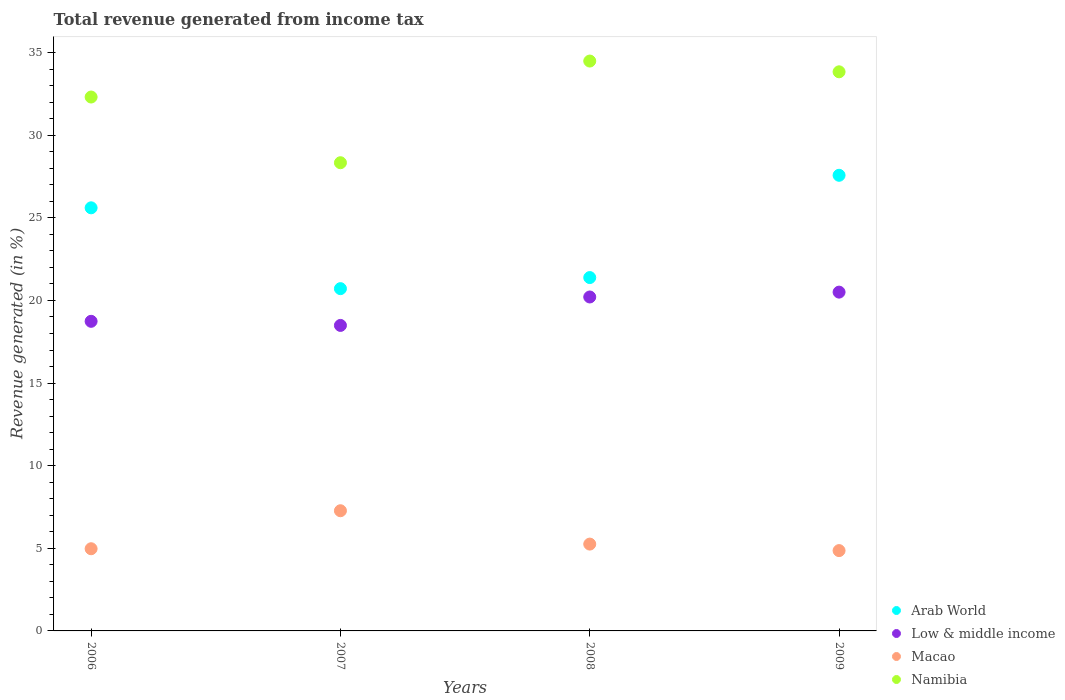How many different coloured dotlines are there?
Your response must be concise. 4. What is the total revenue generated in Macao in 2006?
Your response must be concise. 4.97. Across all years, what is the maximum total revenue generated in Namibia?
Your answer should be compact. 34.49. Across all years, what is the minimum total revenue generated in Namibia?
Offer a terse response. 28.33. What is the total total revenue generated in Namibia in the graph?
Keep it short and to the point. 128.97. What is the difference between the total revenue generated in Arab World in 2007 and that in 2008?
Offer a terse response. -0.67. What is the difference between the total revenue generated in Macao in 2006 and the total revenue generated in Low & middle income in 2007?
Offer a very short reply. -13.52. What is the average total revenue generated in Arab World per year?
Your answer should be very brief. 23.82. In the year 2009, what is the difference between the total revenue generated in Arab World and total revenue generated in Low & middle income?
Ensure brevity in your answer.  7.07. What is the ratio of the total revenue generated in Arab World in 2008 to that in 2009?
Provide a short and direct response. 0.78. Is the total revenue generated in Namibia in 2007 less than that in 2009?
Your answer should be very brief. Yes. What is the difference between the highest and the second highest total revenue generated in Macao?
Ensure brevity in your answer.  2.02. What is the difference between the highest and the lowest total revenue generated in Arab World?
Make the answer very short. 6.86. In how many years, is the total revenue generated in Low & middle income greater than the average total revenue generated in Low & middle income taken over all years?
Make the answer very short. 2. Is it the case that in every year, the sum of the total revenue generated in Arab World and total revenue generated in Macao  is greater than the sum of total revenue generated in Low & middle income and total revenue generated in Namibia?
Your answer should be compact. No. Is it the case that in every year, the sum of the total revenue generated in Namibia and total revenue generated in Arab World  is greater than the total revenue generated in Low & middle income?
Offer a very short reply. Yes. How many years are there in the graph?
Your answer should be very brief. 4. Are the values on the major ticks of Y-axis written in scientific E-notation?
Your answer should be compact. No. Does the graph contain any zero values?
Provide a short and direct response. No. Where does the legend appear in the graph?
Provide a succinct answer. Bottom right. How many legend labels are there?
Your answer should be compact. 4. How are the legend labels stacked?
Make the answer very short. Vertical. What is the title of the graph?
Your answer should be compact. Total revenue generated from income tax. What is the label or title of the X-axis?
Give a very brief answer. Years. What is the label or title of the Y-axis?
Offer a very short reply. Revenue generated (in %). What is the Revenue generated (in %) of Arab World in 2006?
Your answer should be very brief. 25.61. What is the Revenue generated (in %) of Low & middle income in 2006?
Offer a very short reply. 18.74. What is the Revenue generated (in %) of Macao in 2006?
Your answer should be very brief. 4.97. What is the Revenue generated (in %) in Namibia in 2006?
Keep it short and to the point. 32.31. What is the Revenue generated (in %) of Arab World in 2007?
Provide a short and direct response. 20.71. What is the Revenue generated (in %) in Low & middle income in 2007?
Provide a succinct answer. 18.49. What is the Revenue generated (in %) in Macao in 2007?
Ensure brevity in your answer.  7.27. What is the Revenue generated (in %) in Namibia in 2007?
Offer a very short reply. 28.33. What is the Revenue generated (in %) of Arab World in 2008?
Give a very brief answer. 21.38. What is the Revenue generated (in %) of Low & middle income in 2008?
Your answer should be compact. 20.21. What is the Revenue generated (in %) of Macao in 2008?
Provide a short and direct response. 5.25. What is the Revenue generated (in %) in Namibia in 2008?
Your answer should be compact. 34.49. What is the Revenue generated (in %) of Arab World in 2009?
Your answer should be compact. 27.57. What is the Revenue generated (in %) of Low & middle income in 2009?
Your answer should be very brief. 20.5. What is the Revenue generated (in %) in Macao in 2009?
Give a very brief answer. 4.86. What is the Revenue generated (in %) of Namibia in 2009?
Ensure brevity in your answer.  33.84. Across all years, what is the maximum Revenue generated (in %) in Arab World?
Offer a very short reply. 27.57. Across all years, what is the maximum Revenue generated (in %) of Low & middle income?
Ensure brevity in your answer.  20.5. Across all years, what is the maximum Revenue generated (in %) of Macao?
Provide a succinct answer. 7.27. Across all years, what is the maximum Revenue generated (in %) in Namibia?
Ensure brevity in your answer.  34.49. Across all years, what is the minimum Revenue generated (in %) in Arab World?
Give a very brief answer. 20.71. Across all years, what is the minimum Revenue generated (in %) of Low & middle income?
Offer a terse response. 18.49. Across all years, what is the minimum Revenue generated (in %) in Macao?
Ensure brevity in your answer.  4.86. Across all years, what is the minimum Revenue generated (in %) in Namibia?
Provide a succinct answer. 28.33. What is the total Revenue generated (in %) of Arab World in the graph?
Make the answer very short. 95.28. What is the total Revenue generated (in %) in Low & middle income in the graph?
Your answer should be very brief. 77.94. What is the total Revenue generated (in %) of Macao in the graph?
Offer a very short reply. 22.36. What is the total Revenue generated (in %) of Namibia in the graph?
Offer a very short reply. 128.97. What is the difference between the Revenue generated (in %) of Arab World in 2006 and that in 2007?
Offer a very short reply. 4.89. What is the difference between the Revenue generated (in %) in Low & middle income in 2006 and that in 2007?
Make the answer very short. 0.25. What is the difference between the Revenue generated (in %) of Macao in 2006 and that in 2007?
Make the answer very short. -2.3. What is the difference between the Revenue generated (in %) of Namibia in 2006 and that in 2007?
Your answer should be very brief. 3.98. What is the difference between the Revenue generated (in %) of Arab World in 2006 and that in 2008?
Give a very brief answer. 4.22. What is the difference between the Revenue generated (in %) of Low & middle income in 2006 and that in 2008?
Provide a short and direct response. -1.47. What is the difference between the Revenue generated (in %) in Macao in 2006 and that in 2008?
Provide a short and direct response. -0.28. What is the difference between the Revenue generated (in %) in Namibia in 2006 and that in 2008?
Offer a very short reply. -2.18. What is the difference between the Revenue generated (in %) in Arab World in 2006 and that in 2009?
Provide a succinct answer. -1.97. What is the difference between the Revenue generated (in %) of Low & middle income in 2006 and that in 2009?
Your answer should be compact. -1.77. What is the difference between the Revenue generated (in %) of Macao in 2006 and that in 2009?
Make the answer very short. 0.11. What is the difference between the Revenue generated (in %) in Namibia in 2006 and that in 2009?
Your answer should be compact. -1.53. What is the difference between the Revenue generated (in %) in Arab World in 2007 and that in 2008?
Provide a short and direct response. -0.67. What is the difference between the Revenue generated (in %) of Low & middle income in 2007 and that in 2008?
Your answer should be compact. -1.72. What is the difference between the Revenue generated (in %) in Macao in 2007 and that in 2008?
Make the answer very short. 2.02. What is the difference between the Revenue generated (in %) of Namibia in 2007 and that in 2008?
Offer a terse response. -6.15. What is the difference between the Revenue generated (in %) in Arab World in 2007 and that in 2009?
Your response must be concise. -6.86. What is the difference between the Revenue generated (in %) of Low & middle income in 2007 and that in 2009?
Offer a terse response. -2.02. What is the difference between the Revenue generated (in %) in Macao in 2007 and that in 2009?
Keep it short and to the point. 2.41. What is the difference between the Revenue generated (in %) in Namibia in 2007 and that in 2009?
Keep it short and to the point. -5.5. What is the difference between the Revenue generated (in %) of Arab World in 2008 and that in 2009?
Give a very brief answer. -6.19. What is the difference between the Revenue generated (in %) of Low & middle income in 2008 and that in 2009?
Your answer should be compact. -0.29. What is the difference between the Revenue generated (in %) in Macao in 2008 and that in 2009?
Provide a short and direct response. 0.39. What is the difference between the Revenue generated (in %) in Namibia in 2008 and that in 2009?
Your response must be concise. 0.65. What is the difference between the Revenue generated (in %) of Arab World in 2006 and the Revenue generated (in %) of Low & middle income in 2007?
Ensure brevity in your answer.  7.12. What is the difference between the Revenue generated (in %) in Arab World in 2006 and the Revenue generated (in %) in Macao in 2007?
Give a very brief answer. 18.33. What is the difference between the Revenue generated (in %) in Arab World in 2006 and the Revenue generated (in %) in Namibia in 2007?
Keep it short and to the point. -2.73. What is the difference between the Revenue generated (in %) in Low & middle income in 2006 and the Revenue generated (in %) in Macao in 2007?
Make the answer very short. 11.46. What is the difference between the Revenue generated (in %) in Low & middle income in 2006 and the Revenue generated (in %) in Namibia in 2007?
Provide a short and direct response. -9.6. What is the difference between the Revenue generated (in %) in Macao in 2006 and the Revenue generated (in %) in Namibia in 2007?
Offer a terse response. -23.36. What is the difference between the Revenue generated (in %) of Arab World in 2006 and the Revenue generated (in %) of Low & middle income in 2008?
Offer a very short reply. 5.4. What is the difference between the Revenue generated (in %) of Arab World in 2006 and the Revenue generated (in %) of Macao in 2008?
Offer a very short reply. 20.35. What is the difference between the Revenue generated (in %) of Arab World in 2006 and the Revenue generated (in %) of Namibia in 2008?
Your answer should be compact. -8.88. What is the difference between the Revenue generated (in %) in Low & middle income in 2006 and the Revenue generated (in %) in Macao in 2008?
Your response must be concise. 13.48. What is the difference between the Revenue generated (in %) of Low & middle income in 2006 and the Revenue generated (in %) of Namibia in 2008?
Give a very brief answer. -15.75. What is the difference between the Revenue generated (in %) in Macao in 2006 and the Revenue generated (in %) in Namibia in 2008?
Provide a succinct answer. -29.51. What is the difference between the Revenue generated (in %) in Arab World in 2006 and the Revenue generated (in %) in Low & middle income in 2009?
Give a very brief answer. 5.1. What is the difference between the Revenue generated (in %) in Arab World in 2006 and the Revenue generated (in %) in Macao in 2009?
Give a very brief answer. 20.75. What is the difference between the Revenue generated (in %) of Arab World in 2006 and the Revenue generated (in %) of Namibia in 2009?
Your answer should be compact. -8.23. What is the difference between the Revenue generated (in %) in Low & middle income in 2006 and the Revenue generated (in %) in Macao in 2009?
Offer a very short reply. 13.88. What is the difference between the Revenue generated (in %) in Low & middle income in 2006 and the Revenue generated (in %) in Namibia in 2009?
Your answer should be very brief. -15.1. What is the difference between the Revenue generated (in %) of Macao in 2006 and the Revenue generated (in %) of Namibia in 2009?
Make the answer very short. -28.86. What is the difference between the Revenue generated (in %) of Arab World in 2007 and the Revenue generated (in %) of Low & middle income in 2008?
Make the answer very short. 0.5. What is the difference between the Revenue generated (in %) of Arab World in 2007 and the Revenue generated (in %) of Macao in 2008?
Offer a terse response. 15.46. What is the difference between the Revenue generated (in %) of Arab World in 2007 and the Revenue generated (in %) of Namibia in 2008?
Offer a terse response. -13.77. What is the difference between the Revenue generated (in %) in Low & middle income in 2007 and the Revenue generated (in %) in Macao in 2008?
Your answer should be compact. 13.23. What is the difference between the Revenue generated (in %) of Low & middle income in 2007 and the Revenue generated (in %) of Namibia in 2008?
Provide a short and direct response. -16. What is the difference between the Revenue generated (in %) in Macao in 2007 and the Revenue generated (in %) in Namibia in 2008?
Provide a short and direct response. -27.21. What is the difference between the Revenue generated (in %) in Arab World in 2007 and the Revenue generated (in %) in Low & middle income in 2009?
Make the answer very short. 0.21. What is the difference between the Revenue generated (in %) in Arab World in 2007 and the Revenue generated (in %) in Macao in 2009?
Keep it short and to the point. 15.85. What is the difference between the Revenue generated (in %) in Arab World in 2007 and the Revenue generated (in %) in Namibia in 2009?
Provide a short and direct response. -13.12. What is the difference between the Revenue generated (in %) in Low & middle income in 2007 and the Revenue generated (in %) in Macao in 2009?
Your answer should be very brief. 13.63. What is the difference between the Revenue generated (in %) in Low & middle income in 2007 and the Revenue generated (in %) in Namibia in 2009?
Your response must be concise. -15.35. What is the difference between the Revenue generated (in %) of Macao in 2007 and the Revenue generated (in %) of Namibia in 2009?
Give a very brief answer. -26.56. What is the difference between the Revenue generated (in %) of Arab World in 2008 and the Revenue generated (in %) of Low & middle income in 2009?
Your answer should be compact. 0.88. What is the difference between the Revenue generated (in %) in Arab World in 2008 and the Revenue generated (in %) in Macao in 2009?
Your response must be concise. 16.52. What is the difference between the Revenue generated (in %) in Arab World in 2008 and the Revenue generated (in %) in Namibia in 2009?
Offer a terse response. -12.45. What is the difference between the Revenue generated (in %) of Low & middle income in 2008 and the Revenue generated (in %) of Macao in 2009?
Your response must be concise. 15.35. What is the difference between the Revenue generated (in %) of Low & middle income in 2008 and the Revenue generated (in %) of Namibia in 2009?
Give a very brief answer. -13.63. What is the difference between the Revenue generated (in %) of Macao in 2008 and the Revenue generated (in %) of Namibia in 2009?
Provide a succinct answer. -28.58. What is the average Revenue generated (in %) in Arab World per year?
Offer a terse response. 23.82. What is the average Revenue generated (in %) of Low & middle income per year?
Make the answer very short. 19.48. What is the average Revenue generated (in %) in Macao per year?
Your answer should be compact. 5.59. What is the average Revenue generated (in %) of Namibia per year?
Give a very brief answer. 32.24. In the year 2006, what is the difference between the Revenue generated (in %) of Arab World and Revenue generated (in %) of Low & middle income?
Provide a short and direct response. 6.87. In the year 2006, what is the difference between the Revenue generated (in %) in Arab World and Revenue generated (in %) in Macao?
Offer a very short reply. 20.63. In the year 2006, what is the difference between the Revenue generated (in %) of Arab World and Revenue generated (in %) of Namibia?
Provide a succinct answer. -6.7. In the year 2006, what is the difference between the Revenue generated (in %) of Low & middle income and Revenue generated (in %) of Macao?
Offer a terse response. 13.76. In the year 2006, what is the difference between the Revenue generated (in %) in Low & middle income and Revenue generated (in %) in Namibia?
Make the answer very short. -13.57. In the year 2006, what is the difference between the Revenue generated (in %) of Macao and Revenue generated (in %) of Namibia?
Your answer should be compact. -27.34. In the year 2007, what is the difference between the Revenue generated (in %) in Arab World and Revenue generated (in %) in Low & middle income?
Keep it short and to the point. 2.23. In the year 2007, what is the difference between the Revenue generated (in %) in Arab World and Revenue generated (in %) in Macao?
Offer a very short reply. 13.44. In the year 2007, what is the difference between the Revenue generated (in %) of Arab World and Revenue generated (in %) of Namibia?
Offer a terse response. -7.62. In the year 2007, what is the difference between the Revenue generated (in %) in Low & middle income and Revenue generated (in %) in Macao?
Provide a succinct answer. 11.22. In the year 2007, what is the difference between the Revenue generated (in %) of Low & middle income and Revenue generated (in %) of Namibia?
Give a very brief answer. -9.85. In the year 2007, what is the difference between the Revenue generated (in %) in Macao and Revenue generated (in %) in Namibia?
Give a very brief answer. -21.06. In the year 2008, what is the difference between the Revenue generated (in %) in Arab World and Revenue generated (in %) in Low & middle income?
Provide a succinct answer. 1.18. In the year 2008, what is the difference between the Revenue generated (in %) in Arab World and Revenue generated (in %) in Macao?
Your answer should be very brief. 16.13. In the year 2008, what is the difference between the Revenue generated (in %) of Arab World and Revenue generated (in %) of Namibia?
Make the answer very short. -13.1. In the year 2008, what is the difference between the Revenue generated (in %) of Low & middle income and Revenue generated (in %) of Macao?
Offer a terse response. 14.95. In the year 2008, what is the difference between the Revenue generated (in %) of Low & middle income and Revenue generated (in %) of Namibia?
Offer a terse response. -14.28. In the year 2008, what is the difference between the Revenue generated (in %) in Macao and Revenue generated (in %) in Namibia?
Provide a short and direct response. -29.23. In the year 2009, what is the difference between the Revenue generated (in %) in Arab World and Revenue generated (in %) in Low & middle income?
Ensure brevity in your answer.  7.07. In the year 2009, what is the difference between the Revenue generated (in %) in Arab World and Revenue generated (in %) in Macao?
Make the answer very short. 22.71. In the year 2009, what is the difference between the Revenue generated (in %) of Arab World and Revenue generated (in %) of Namibia?
Offer a very short reply. -6.26. In the year 2009, what is the difference between the Revenue generated (in %) in Low & middle income and Revenue generated (in %) in Macao?
Give a very brief answer. 15.64. In the year 2009, what is the difference between the Revenue generated (in %) of Low & middle income and Revenue generated (in %) of Namibia?
Offer a terse response. -13.33. In the year 2009, what is the difference between the Revenue generated (in %) in Macao and Revenue generated (in %) in Namibia?
Ensure brevity in your answer.  -28.98. What is the ratio of the Revenue generated (in %) of Arab World in 2006 to that in 2007?
Offer a very short reply. 1.24. What is the ratio of the Revenue generated (in %) in Low & middle income in 2006 to that in 2007?
Offer a terse response. 1.01. What is the ratio of the Revenue generated (in %) of Macao in 2006 to that in 2007?
Your response must be concise. 0.68. What is the ratio of the Revenue generated (in %) of Namibia in 2006 to that in 2007?
Offer a very short reply. 1.14. What is the ratio of the Revenue generated (in %) in Arab World in 2006 to that in 2008?
Provide a short and direct response. 1.2. What is the ratio of the Revenue generated (in %) of Low & middle income in 2006 to that in 2008?
Give a very brief answer. 0.93. What is the ratio of the Revenue generated (in %) in Macao in 2006 to that in 2008?
Your answer should be very brief. 0.95. What is the ratio of the Revenue generated (in %) of Namibia in 2006 to that in 2008?
Keep it short and to the point. 0.94. What is the ratio of the Revenue generated (in %) of Arab World in 2006 to that in 2009?
Give a very brief answer. 0.93. What is the ratio of the Revenue generated (in %) in Low & middle income in 2006 to that in 2009?
Give a very brief answer. 0.91. What is the ratio of the Revenue generated (in %) in Macao in 2006 to that in 2009?
Ensure brevity in your answer.  1.02. What is the ratio of the Revenue generated (in %) of Namibia in 2006 to that in 2009?
Offer a terse response. 0.95. What is the ratio of the Revenue generated (in %) of Arab World in 2007 to that in 2008?
Give a very brief answer. 0.97. What is the ratio of the Revenue generated (in %) in Low & middle income in 2007 to that in 2008?
Your answer should be very brief. 0.91. What is the ratio of the Revenue generated (in %) of Macao in 2007 to that in 2008?
Ensure brevity in your answer.  1.38. What is the ratio of the Revenue generated (in %) of Namibia in 2007 to that in 2008?
Make the answer very short. 0.82. What is the ratio of the Revenue generated (in %) of Arab World in 2007 to that in 2009?
Ensure brevity in your answer.  0.75. What is the ratio of the Revenue generated (in %) of Low & middle income in 2007 to that in 2009?
Offer a very short reply. 0.9. What is the ratio of the Revenue generated (in %) in Macao in 2007 to that in 2009?
Your answer should be compact. 1.5. What is the ratio of the Revenue generated (in %) of Namibia in 2007 to that in 2009?
Your answer should be very brief. 0.84. What is the ratio of the Revenue generated (in %) of Arab World in 2008 to that in 2009?
Ensure brevity in your answer.  0.78. What is the ratio of the Revenue generated (in %) in Low & middle income in 2008 to that in 2009?
Provide a succinct answer. 0.99. What is the ratio of the Revenue generated (in %) in Macao in 2008 to that in 2009?
Offer a very short reply. 1.08. What is the ratio of the Revenue generated (in %) of Namibia in 2008 to that in 2009?
Offer a terse response. 1.02. What is the difference between the highest and the second highest Revenue generated (in %) in Arab World?
Offer a terse response. 1.97. What is the difference between the highest and the second highest Revenue generated (in %) in Low & middle income?
Your answer should be compact. 0.29. What is the difference between the highest and the second highest Revenue generated (in %) in Macao?
Provide a short and direct response. 2.02. What is the difference between the highest and the second highest Revenue generated (in %) in Namibia?
Offer a terse response. 0.65. What is the difference between the highest and the lowest Revenue generated (in %) in Arab World?
Provide a succinct answer. 6.86. What is the difference between the highest and the lowest Revenue generated (in %) of Low & middle income?
Your answer should be compact. 2.02. What is the difference between the highest and the lowest Revenue generated (in %) in Macao?
Ensure brevity in your answer.  2.41. What is the difference between the highest and the lowest Revenue generated (in %) in Namibia?
Keep it short and to the point. 6.15. 